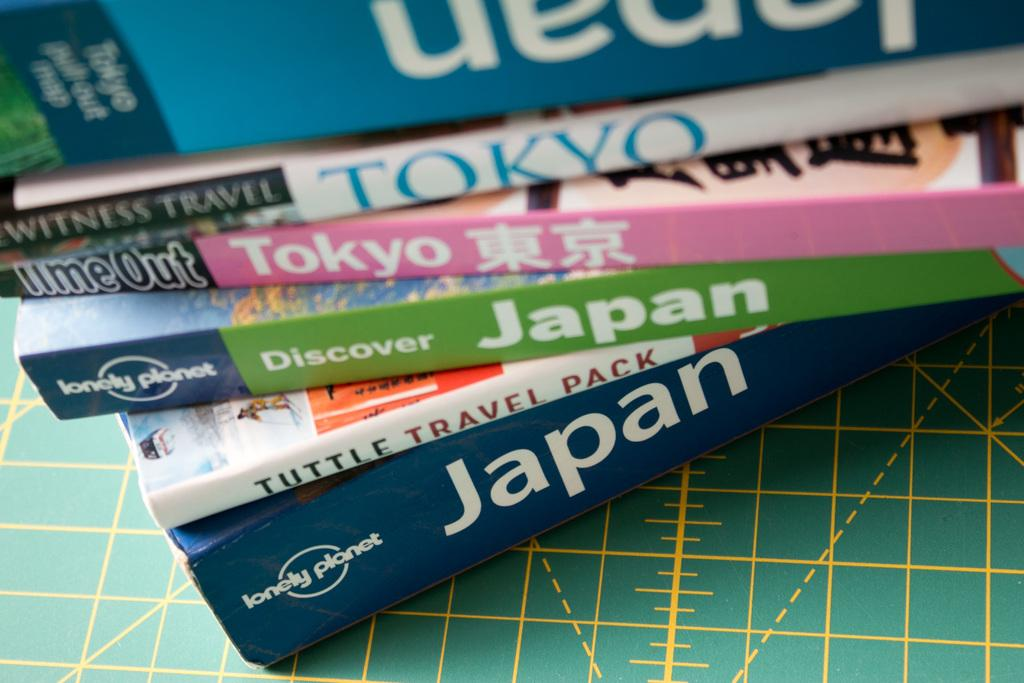<image>
Present a compact description of the photo's key features. A stack of Tokyo and Japan books on a table. 